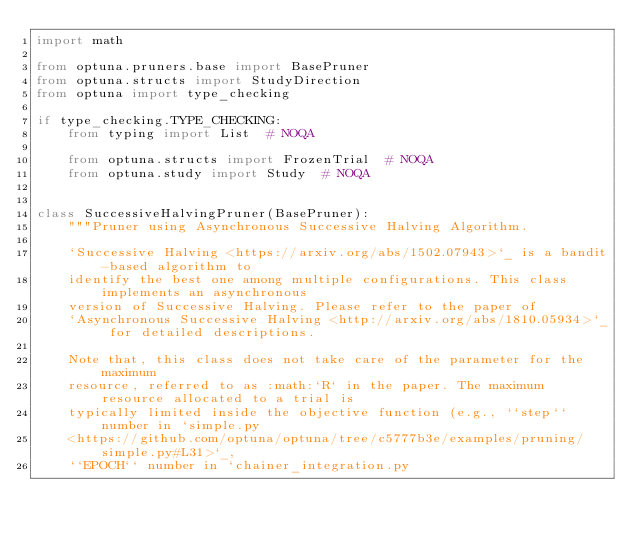<code> <loc_0><loc_0><loc_500><loc_500><_Python_>import math

from optuna.pruners.base import BasePruner
from optuna.structs import StudyDirection
from optuna import type_checking

if type_checking.TYPE_CHECKING:
    from typing import List  # NOQA

    from optuna.structs import FrozenTrial  # NOQA
    from optuna.study import Study  # NOQA


class SuccessiveHalvingPruner(BasePruner):
    """Pruner using Asynchronous Successive Halving Algorithm.

    `Successive Halving <https://arxiv.org/abs/1502.07943>`_ is a bandit-based algorithm to
    identify the best one among multiple configurations. This class implements an asynchronous
    version of Successive Halving. Please refer to the paper of
    `Asynchronous Successive Halving <http://arxiv.org/abs/1810.05934>`_ for detailed descriptions.

    Note that, this class does not take care of the parameter for the maximum
    resource, referred to as :math:`R` in the paper. The maximum resource allocated to a trial is
    typically limited inside the objective function (e.g., ``step`` number in `simple.py
    <https://github.com/optuna/optuna/tree/c5777b3e/examples/pruning/simple.py#L31>`_,
    ``EPOCH`` number in `chainer_integration.py</code> 